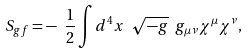Convert formula to latex. <formula><loc_0><loc_0><loc_500><loc_500>S _ { g f } = - \ \frac { 1 } { 2 } \int d ^ { 4 } x \ \sqrt { - g } \ g _ { \mu \nu } \chi ^ { \mu } \chi ^ { \nu } ,</formula> 